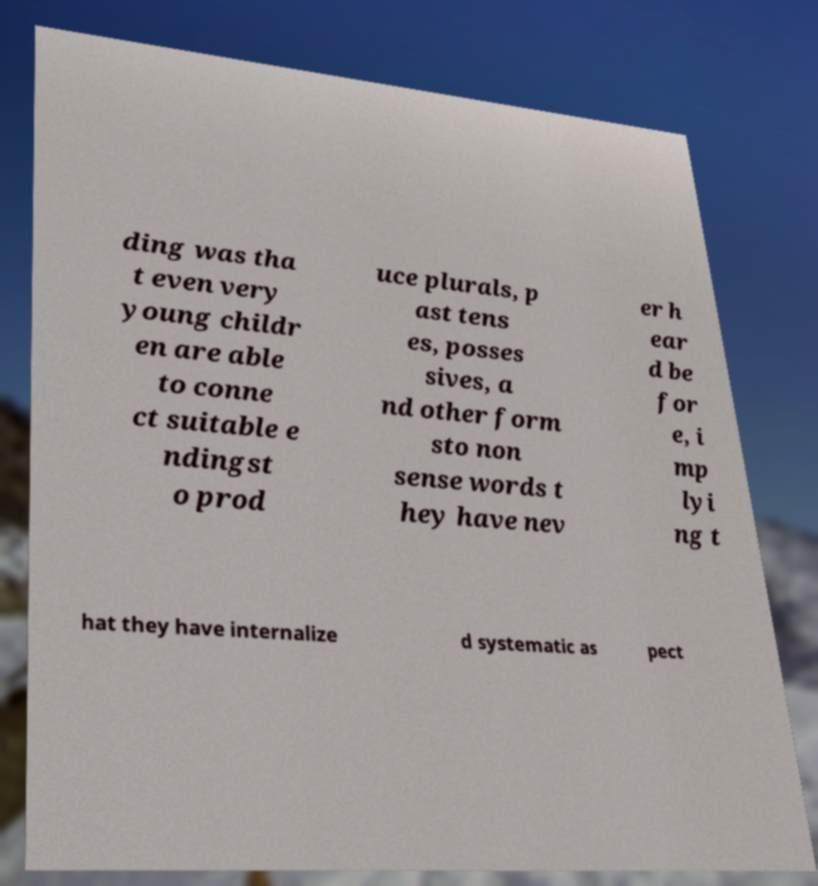I need the written content from this picture converted into text. Can you do that? ding was tha t even very young childr en are able to conne ct suitable e ndingst o prod uce plurals, p ast tens es, posses sives, a nd other form sto non sense words t hey have nev er h ear d be for e, i mp lyi ng t hat they have internalize d systematic as pect 